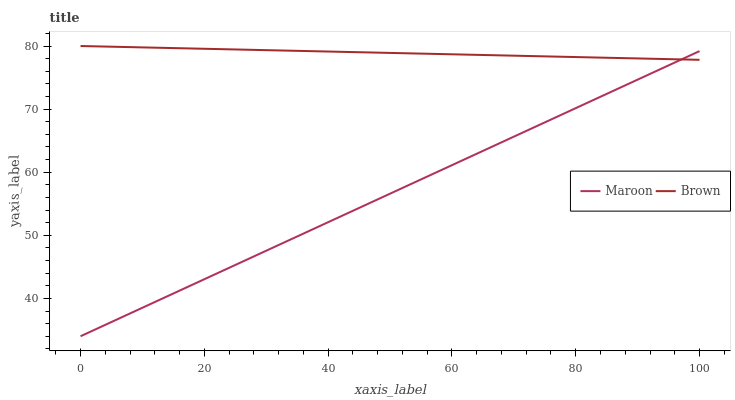Does Maroon have the minimum area under the curve?
Answer yes or no. Yes. Does Brown have the maximum area under the curve?
Answer yes or no. Yes. Does Maroon have the maximum area under the curve?
Answer yes or no. No. Is Maroon the smoothest?
Answer yes or no. Yes. Is Brown the roughest?
Answer yes or no. Yes. Is Maroon the roughest?
Answer yes or no. No. Does Maroon have the lowest value?
Answer yes or no. Yes. Does Brown have the highest value?
Answer yes or no. Yes. Does Maroon have the highest value?
Answer yes or no. No. Does Brown intersect Maroon?
Answer yes or no. Yes. Is Brown less than Maroon?
Answer yes or no. No. Is Brown greater than Maroon?
Answer yes or no. No. 